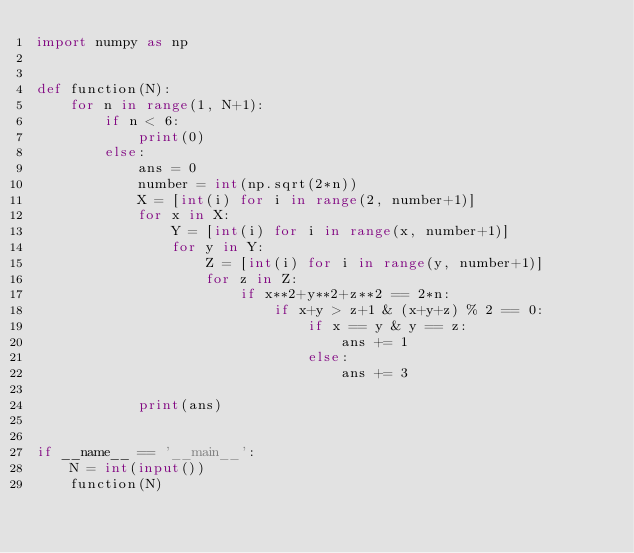<code> <loc_0><loc_0><loc_500><loc_500><_Python_>import numpy as np


def function(N):
    for n in range(1, N+1):
        if n < 6:
            print(0)
        else:
            ans = 0
            number = int(np.sqrt(2*n))
            X = [int(i) for i in range(2, number+1)]
            for x in X:
                Y = [int(i) for i in range(x, number+1)]
                for y in Y:
                    Z = [int(i) for i in range(y, number+1)]
                    for z in Z:
                        if x**2+y**2+z**2 == 2*n:
                            if x+y > z+1 & (x+y+z) % 2 == 0:
                                if x == y & y == z:
                                    ans += 1
                                else:
                                    ans += 3

            print(ans)


if __name__ == '__main__':
    N = int(input())
    function(N)
</code> 